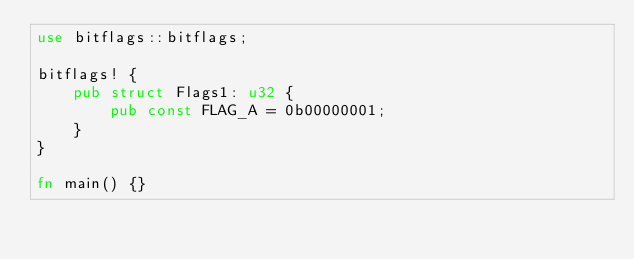<code> <loc_0><loc_0><loc_500><loc_500><_Rust_>use bitflags::bitflags;

bitflags! {
    pub struct Flags1: u32 {
        pub const FLAG_A = 0b00000001;
    }
}

fn main() {}
</code> 